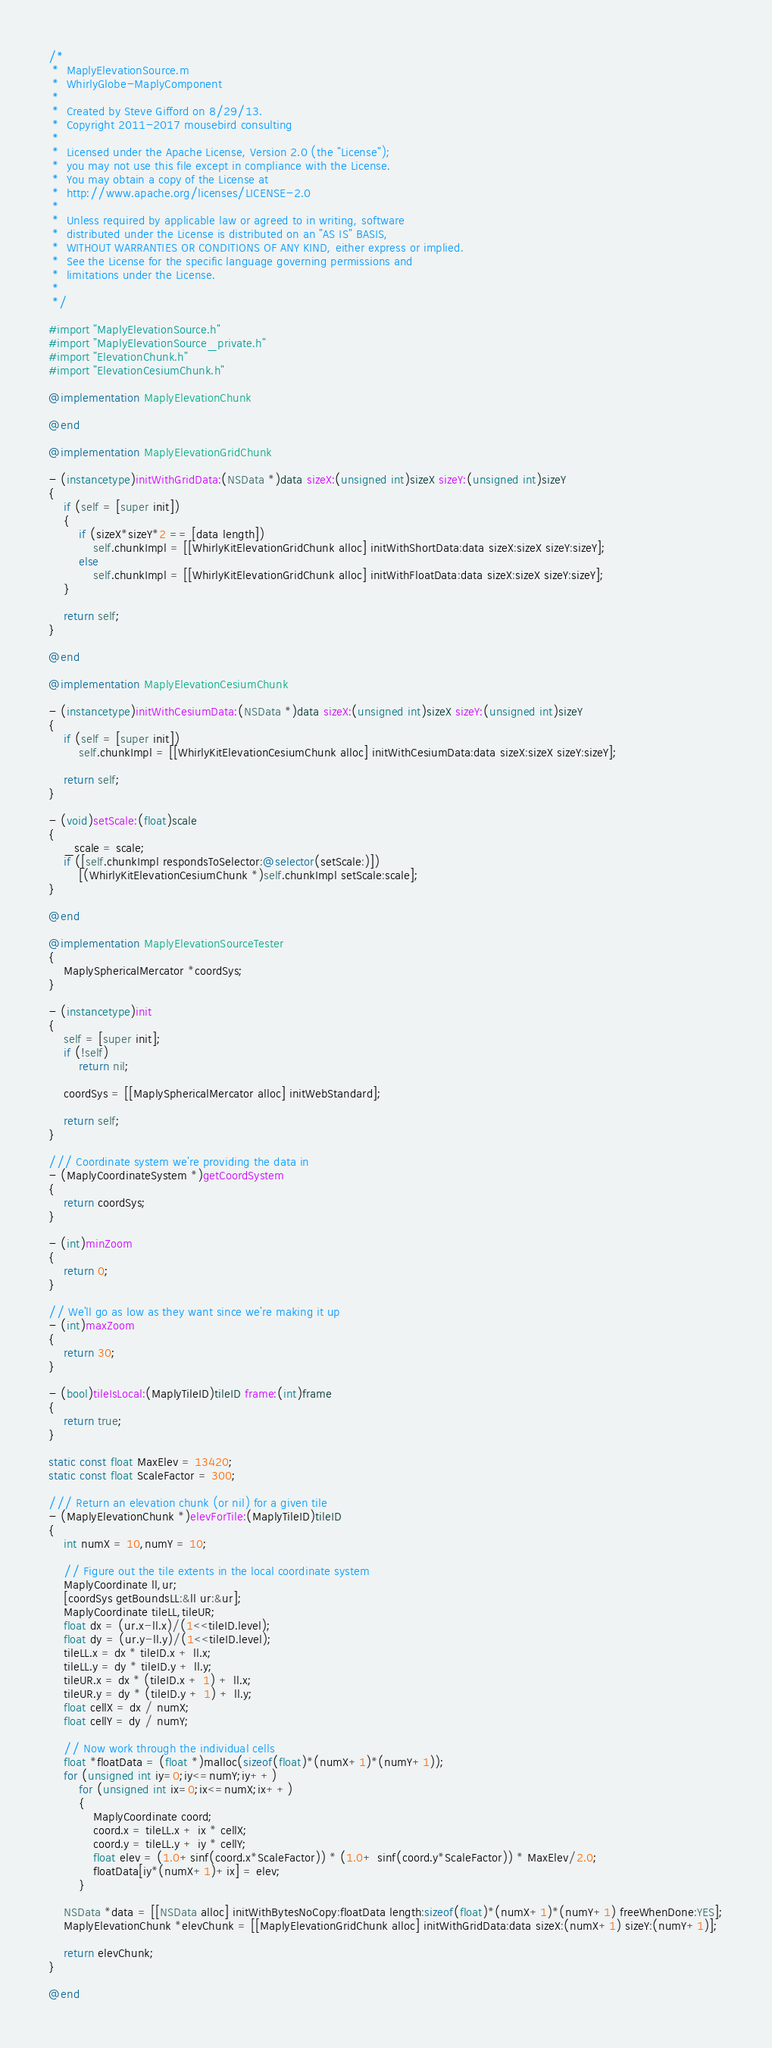Convert code to text. <code><loc_0><loc_0><loc_500><loc_500><_ObjectiveC_>/*
 *  MaplyElevationSource.m
 *  WhirlyGlobe-MaplyComponent
 *
 *  Created by Steve Gifford on 8/29/13.
 *  Copyright 2011-2017 mousebird consulting
 *
 *  Licensed under the Apache License, Version 2.0 (the "License");
 *  you may not use this file except in compliance with the License.
 *  You may obtain a copy of the License at
 *  http://www.apache.org/licenses/LICENSE-2.0
 *
 *  Unless required by applicable law or agreed to in writing, software
 *  distributed under the License is distributed on an "AS IS" BASIS,
 *  WITHOUT WARRANTIES OR CONDITIONS OF ANY KIND, either express or implied.
 *  See the License for the specific language governing permissions and
 *  limitations under the License.
 *
 */

#import "MaplyElevationSource.h"
#import "MaplyElevationSource_private.h"
#import "ElevationChunk.h"
#import "ElevationCesiumChunk.h"

@implementation MaplyElevationChunk

@end

@implementation MaplyElevationGridChunk

- (instancetype)initWithGridData:(NSData *)data sizeX:(unsigned int)sizeX sizeY:(unsigned int)sizeY
{
    if (self = [super init])
    {
        if (sizeX*sizeY*2 == [data length])
            self.chunkImpl = [[WhirlyKitElevationGridChunk alloc] initWithShortData:data sizeX:sizeX sizeY:sizeY];
        else
            self.chunkImpl = [[WhirlyKitElevationGridChunk alloc] initWithFloatData:data sizeX:sizeX sizeY:sizeY];
    }
    
    return self;
}

@end

@implementation MaplyElevationCesiumChunk

- (instancetype)initWithCesiumData:(NSData *)data sizeX:(unsigned int)sizeX sizeY:(unsigned int)sizeY
{
    if (self = [super init])
        self.chunkImpl = [[WhirlyKitElevationCesiumChunk alloc] initWithCesiumData:data sizeX:sizeX sizeY:sizeY];
    
    return self;
}

- (void)setScale:(float)scale
{
    _scale = scale;
    if ([self.chunkImpl respondsToSelector:@selector(setScale:)])
        [(WhirlyKitElevationCesiumChunk *)self.chunkImpl setScale:scale];
}

@end

@implementation MaplyElevationSourceTester
{
    MaplySphericalMercator *coordSys;
}

- (instancetype)init
{
    self = [super init];
    if (!self)
        return nil;
    
    coordSys = [[MaplySphericalMercator alloc] initWebStandard];
    
    return self;
}

/// Coordinate system we're providing the data in
- (MaplyCoordinateSystem *)getCoordSystem
{
    return coordSys;
}

- (int)minZoom
{
    return 0;
}

// We'll go as low as they want since we're making it up
- (int)maxZoom
{
    return 30;
}

- (bool)tileIsLocal:(MaplyTileID)tileID frame:(int)frame
{
    return true;
}

static const float MaxElev = 13420;
static const float ScaleFactor = 300;

/// Return an elevation chunk (or nil) for a given tile
- (MaplyElevationChunk *)elevForTile:(MaplyTileID)tileID
{
    int numX = 10,numY = 10;

    // Figure out the tile extents in the local coordinate system
    MaplyCoordinate ll,ur;
    [coordSys getBoundsLL:&ll ur:&ur];
    MaplyCoordinate tileLL,tileUR;
    float dx = (ur.x-ll.x)/(1<<tileID.level);
    float dy = (ur.y-ll.y)/(1<<tileID.level);
    tileLL.x = dx * tileID.x + ll.x;
    tileLL.y = dy * tileID.y + ll.y;
    tileUR.x = dx * (tileID.x + 1) + ll.x;
    tileUR.y = dy * (tileID.y + 1) + ll.y;
    float cellX = dx / numX;
    float cellY = dy / numY;

    // Now work through the individual cells
    float *floatData = (float *)malloc(sizeof(float)*(numX+1)*(numY+1));
    for (unsigned int iy=0;iy<=numY;iy++)
        for (unsigned int ix=0;ix<=numX;ix++)
        {
            MaplyCoordinate coord;
            coord.x = tileLL.x + ix * cellX;
            coord.y = tileLL.y + iy * cellY;
            float elev = (1.0+sinf(coord.x*ScaleFactor)) * (1.0+ sinf(coord.y*ScaleFactor)) * MaxElev/2.0;
            floatData[iy*(numX+1)+ix] = elev;
        }
    
    NSData *data = [[NSData alloc] initWithBytesNoCopy:floatData length:sizeof(float)*(numX+1)*(numY+1) freeWhenDone:YES];
    MaplyElevationChunk *elevChunk = [[MaplyElevationGridChunk alloc] initWithGridData:data sizeX:(numX+1) sizeY:(numY+1)];
    
    return elevChunk;
}

@end
</code> 